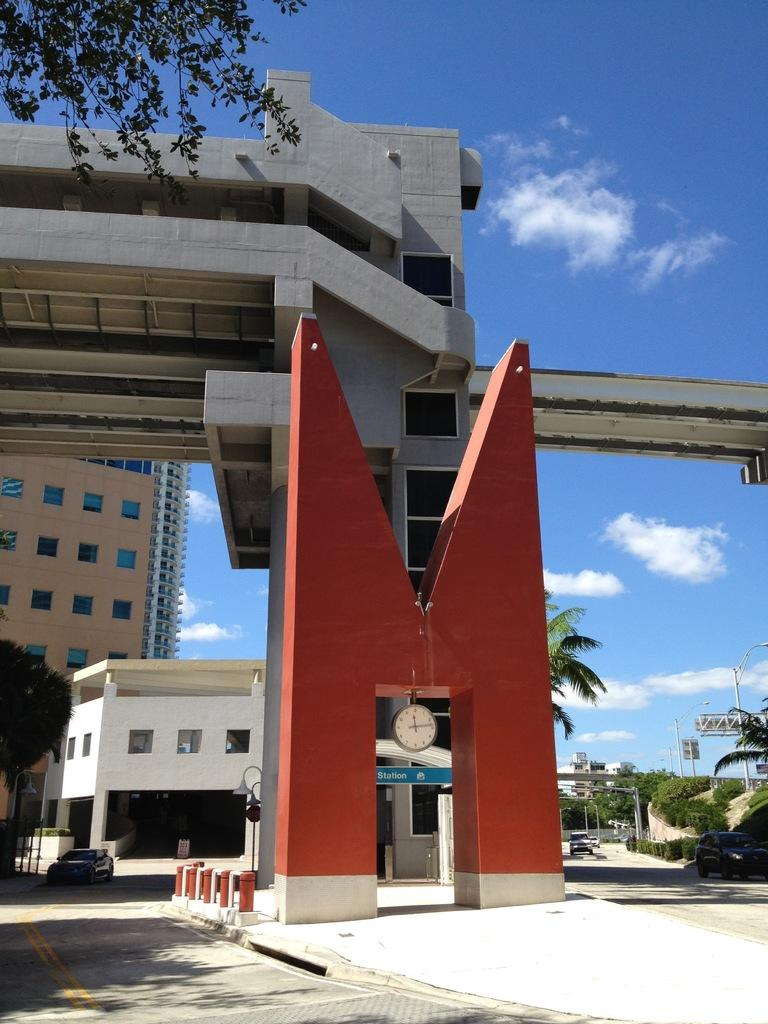What type of structures can be seen in the image? There are buildings in the image. What is the purpose of the fence in the image? The purpose of the fence is to provide a barrier or boundary. What type of vegetation is present in the image? There are trees in the image. What are the poles used for in the image? The poles may be used for various purposes, such as supporting wires or signs. What can be seen through the windows in the image? The contents of the rooms or the view outside the windows can be seen. What part of the natural environment is visible in the image? The sky is visible in the image. Based on the presence of the sky and the absence of artificial lighting, can we determine the time of day the image was taken? Yes, the image was likely taken during the day. Can you tell me how many quills are sticking out of the crate in the image? There is no crate or quills present in the image. What type of measurement can be seen on the poles in the image? There is no measurement visible on the poles in the image. 